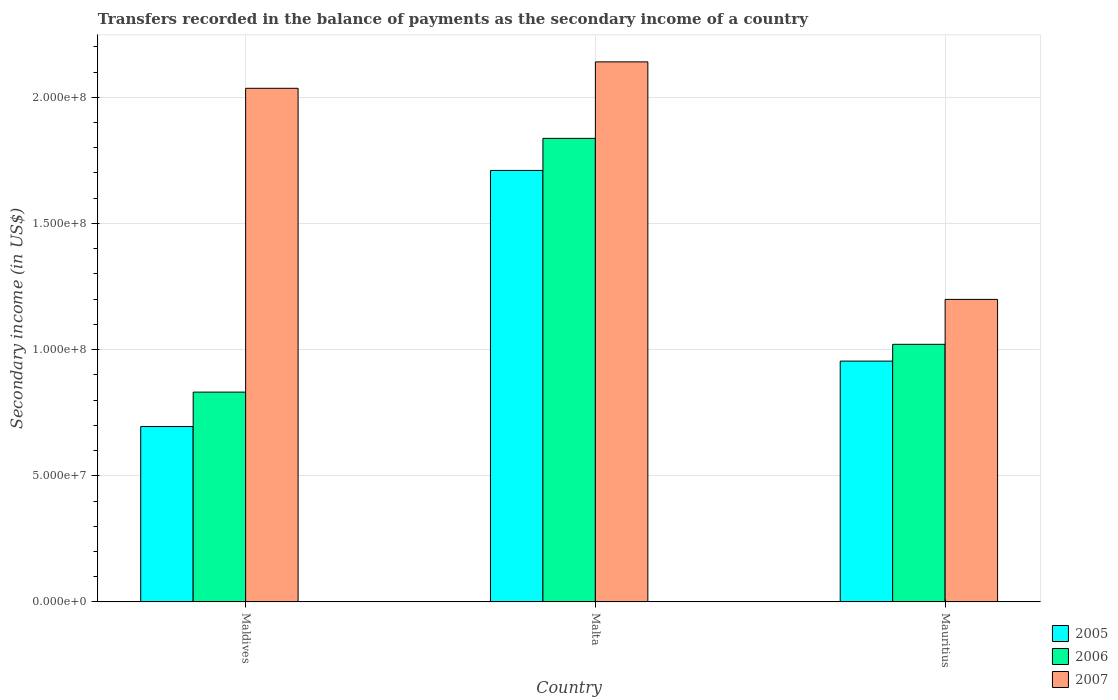What is the label of the 3rd group of bars from the left?
Offer a very short reply. Mauritius. In how many cases, is the number of bars for a given country not equal to the number of legend labels?
Offer a very short reply. 0. What is the secondary income of in 2007 in Mauritius?
Offer a terse response. 1.20e+08. Across all countries, what is the maximum secondary income of in 2007?
Offer a very short reply. 2.14e+08. Across all countries, what is the minimum secondary income of in 2006?
Provide a succinct answer. 8.32e+07. In which country was the secondary income of in 2006 maximum?
Ensure brevity in your answer.  Malta. In which country was the secondary income of in 2005 minimum?
Your response must be concise. Maldives. What is the total secondary income of in 2006 in the graph?
Your answer should be compact. 3.69e+08. What is the difference between the secondary income of in 2007 in Maldives and that in Mauritius?
Keep it short and to the point. 8.36e+07. What is the difference between the secondary income of in 2005 in Malta and the secondary income of in 2006 in Maldives?
Ensure brevity in your answer.  8.78e+07. What is the average secondary income of in 2005 per country?
Provide a short and direct response. 1.12e+08. What is the difference between the secondary income of of/in 2006 and secondary income of of/in 2005 in Malta?
Offer a terse response. 1.27e+07. In how many countries, is the secondary income of in 2006 greater than 210000000 US$?
Provide a succinct answer. 0. What is the ratio of the secondary income of in 2005 in Malta to that in Mauritius?
Your response must be concise. 1.79. Is the secondary income of in 2007 in Malta less than that in Mauritius?
Offer a very short reply. No. Is the difference between the secondary income of in 2006 in Maldives and Malta greater than the difference between the secondary income of in 2005 in Maldives and Malta?
Make the answer very short. Yes. What is the difference between the highest and the second highest secondary income of in 2006?
Make the answer very short. 1.89e+07. What is the difference between the highest and the lowest secondary income of in 2005?
Make the answer very short. 1.01e+08. Is the sum of the secondary income of in 2006 in Malta and Mauritius greater than the maximum secondary income of in 2005 across all countries?
Provide a succinct answer. Yes. What does the 1st bar from the left in Malta represents?
Your response must be concise. 2005. Is it the case that in every country, the sum of the secondary income of in 2005 and secondary income of in 2006 is greater than the secondary income of in 2007?
Your response must be concise. No. Are all the bars in the graph horizontal?
Make the answer very short. No. What is the difference between two consecutive major ticks on the Y-axis?
Offer a terse response. 5.00e+07. Are the values on the major ticks of Y-axis written in scientific E-notation?
Offer a very short reply. Yes. Does the graph contain grids?
Offer a very short reply. Yes. How many legend labels are there?
Provide a succinct answer. 3. How are the legend labels stacked?
Keep it short and to the point. Vertical. What is the title of the graph?
Provide a short and direct response. Transfers recorded in the balance of payments as the secondary income of a country. Does "1991" appear as one of the legend labels in the graph?
Ensure brevity in your answer.  No. What is the label or title of the Y-axis?
Ensure brevity in your answer.  Secondary income (in US$). What is the Secondary income (in US$) in 2005 in Maldives?
Make the answer very short. 6.95e+07. What is the Secondary income (in US$) in 2006 in Maldives?
Offer a very short reply. 8.32e+07. What is the Secondary income (in US$) of 2007 in Maldives?
Ensure brevity in your answer.  2.04e+08. What is the Secondary income (in US$) of 2005 in Malta?
Offer a terse response. 1.71e+08. What is the Secondary income (in US$) of 2006 in Malta?
Offer a terse response. 1.84e+08. What is the Secondary income (in US$) of 2007 in Malta?
Ensure brevity in your answer.  2.14e+08. What is the Secondary income (in US$) of 2005 in Mauritius?
Provide a succinct answer. 9.54e+07. What is the Secondary income (in US$) in 2006 in Mauritius?
Offer a terse response. 1.02e+08. What is the Secondary income (in US$) in 2007 in Mauritius?
Provide a short and direct response. 1.20e+08. Across all countries, what is the maximum Secondary income (in US$) of 2005?
Provide a succinct answer. 1.71e+08. Across all countries, what is the maximum Secondary income (in US$) of 2006?
Provide a succinct answer. 1.84e+08. Across all countries, what is the maximum Secondary income (in US$) of 2007?
Give a very brief answer. 2.14e+08. Across all countries, what is the minimum Secondary income (in US$) in 2005?
Ensure brevity in your answer.  6.95e+07. Across all countries, what is the minimum Secondary income (in US$) of 2006?
Provide a succinct answer. 8.32e+07. Across all countries, what is the minimum Secondary income (in US$) of 2007?
Your answer should be compact. 1.20e+08. What is the total Secondary income (in US$) in 2005 in the graph?
Offer a very short reply. 3.36e+08. What is the total Secondary income (in US$) in 2006 in the graph?
Keep it short and to the point. 3.69e+08. What is the total Secondary income (in US$) of 2007 in the graph?
Your answer should be compact. 5.37e+08. What is the difference between the Secondary income (in US$) of 2005 in Maldives and that in Malta?
Give a very brief answer. -1.01e+08. What is the difference between the Secondary income (in US$) of 2006 in Maldives and that in Malta?
Offer a terse response. -1.01e+08. What is the difference between the Secondary income (in US$) in 2007 in Maldives and that in Malta?
Your answer should be compact. -1.05e+07. What is the difference between the Secondary income (in US$) of 2005 in Maldives and that in Mauritius?
Provide a short and direct response. -2.59e+07. What is the difference between the Secondary income (in US$) of 2006 in Maldives and that in Mauritius?
Give a very brief answer. -1.89e+07. What is the difference between the Secondary income (in US$) in 2007 in Maldives and that in Mauritius?
Offer a very short reply. 8.36e+07. What is the difference between the Secondary income (in US$) in 2005 in Malta and that in Mauritius?
Provide a succinct answer. 7.56e+07. What is the difference between the Secondary income (in US$) of 2006 in Malta and that in Mauritius?
Provide a succinct answer. 8.16e+07. What is the difference between the Secondary income (in US$) in 2007 in Malta and that in Mauritius?
Offer a terse response. 9.41e+07. What is the difference between the Secondary income (in US$) in 2005 in Maldives and the Secondary income (in US$) in 2006 in Malta?
Provide a succinct answer. -1.14e+08. What is the difference between the Secondary income (in US$) of 2005 in Maldives and the Secondary income (in US$) of 2007 in Malta?
Your response must be concise. -1.45e+08. What is the difference between the Secondary income (in US$) of 2006 in Maldives and the Secondary income (in US$) of 2007 in Malta?
Offer a terse response. -1.31e+08. What is the difference between the Secondary income (in US$) in 2005 in Maldives and the Secondary income (in US$) in 2006 in Mauritius?
Make the answer very short. -3.26e+07. What is the difference between the Secondary income (in US$) of 2005 in Maldives and the Secondary income (in US$) of 2007 in Mauritius?
Provide a short and direct response. -5.04e+07. What is the difference between the Secondary income (in US$) of 2006 in Maldives and the Secondary income (in US$) of 2007 in Mauritius?
Provide a short and direct response. -3.67e+07. What is the difference between the Secondary income (in US$) in 2005 in Malta and the Secondary income (in US$) in 2006 in Mauritius?
Offer a very short reply. 6.89e+07. What is the difference between the Secondary income (in US$) of 2005 in Malta and the Secondary income (in US$) of 2007 in Mauritius?
Your answer should be compact. 5.11e+07. What is the difference between the Secondary income (in US$) in 2006 in Malta and the Secondary income (in US$) in 2007 in Mauritius?
Your answer should be compact. 6.38e+07. What is the average Secondary income (in US$) of 2005 per country?
Make the answer very short. 1.12e+08. What is the average Secondary income (in US$) of 2006 per country?
Your response must be concise. 1.23e+08. What is the average Secondary income (in US$) in 2007 per country?
Your answer should be very brief. 1.79e+08. What is the difference between the Secondary income (in US$) in 2005 and Secondary income (in US$) in 2006 in Maldives?
Ensure brevity in your answer.  -1.36e+07. What is the difference between the Secondary income (in US$) of 2005 and Secondary income (in US$) of 2007 in Maldives?
Your answer should be compact. -1.34e+08. What is the difference between the Secondary income (in US$) in 2006 and Secondary income (in US$) in 2007 in Maldives?
Make the answer very short. -1.20e+08. What is the difference between the Secondary income (in US$) of 2005 and Secondary income (in US$) of 2006 in Malta?
Give a very brief answer. -1.27e+07. What is the difference between the Secondary income (in US$) in 2005 and Secondary income (in US$) in 2007 in Malta?
Your answer should be compact. -4.30e+07. What is the difference between the Secondary income (in US$) of 2006 and Secondary income (in US$) of 2007 in Malta?
Your answer should be very brief. -3.03e+07. What is the difference between the Secondary income (in US$) of 2005 and Secondary income (in US$) of 2006 in Mauritius?
Offer a very short reply. -6.65e+06. What is the difference between the Secondary income (in US$) in 2005 and Secondary income (in US$) in 2007 in Mauritius?
Your response must be concise. -2.45e+07. What is the difference between the Secondary income (in US$) in 2006 and Secondary income (in US$) in 2007 in Mauritius?
Your answer should be compact. -1.78e+07. What is the ratio of the Secondary income (in US$) in 2005 in Maldives to that in Malta?
Provide a succinct answer. 0.41. What is the ratio of the Secondary income (in US$) in 2006 in Maldives to that in Malta?
Make the answer very short. 0.45. What is the ratio of the Secondary income (in US$) of 2007 in Maldives to that in Malta?
Your answer should be compact. 0.95. What is the ratio of the Secondary income (in US$) of 2005 in Maldives to that in Mauritius?
Ensure brevity in your answer.  0.73. What is the ratio of the Secondary income (in US$) of 2006 in Maldives to that in Mauritius?
Provide a succinct answer. 0.81. What is the ratio of the Secondary income (in US$) in 2007 in Maldives to that in Mauritius?
Provide a short and direct response. 1.7. What is the ratio of the Secondary income (in US$) in 2005 in Malta to that in Mauritius?
Your answer should be compact. 1.79. What is the ratio of the Secondary income (in US$) of 2006 in Malta to that in Mauritius?
Keep it short and to the point. 1.8. What is the ratio of the Secondary income (in US$) in 2007 in Malta to that in Mauritius?
Offer a terse response. 1.78. What is the difference between the highest and the second highest Secondary income (in US$) in 2005?
Your response must be concise. 7.56e+07. What is the difference between the highest and the second highest Secondary income (in US$) of 2006?
Offer a terse response. 8.16e+07. What is the difference between the highest and the second highest Secondary income (in US$) of 2007?
Make the answer very short. 1.05e+07. What is the difference between the highest and the lowest Secondary income (in US$) of 2005?
Ensure brevity in your answer.  1.01e+08. What is the difference between the highest and the lowest Secondary income (in US$) in 2006?
Keep it short and to the point. 1.01e+08. What is the difference between the highest and the lowest Secondary income (in US$) in 2007?
Ensure brevity in your answer.  9.41e+07. 